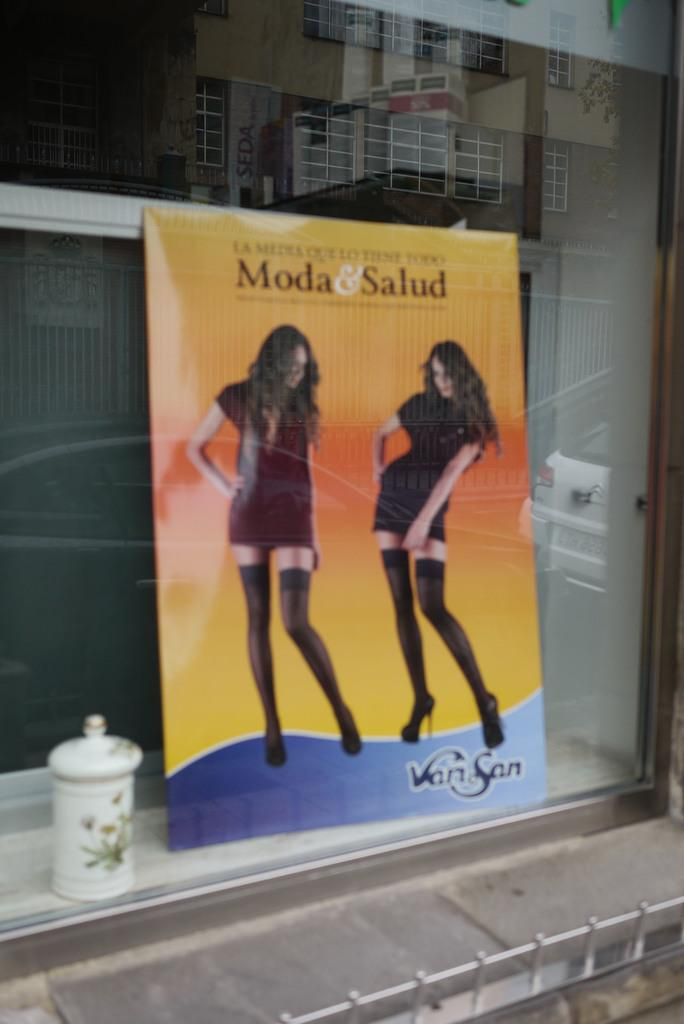What is the main object in the image? There is a hoarding in the image. What is located beside the hoarding? There is a dustbin beside the hoarding. Can you describe something in the background of the image? There is a glass visible in the background of the image. What record is being set by the smoke in the image? There is no smoke present in the image, so no record can be set. 